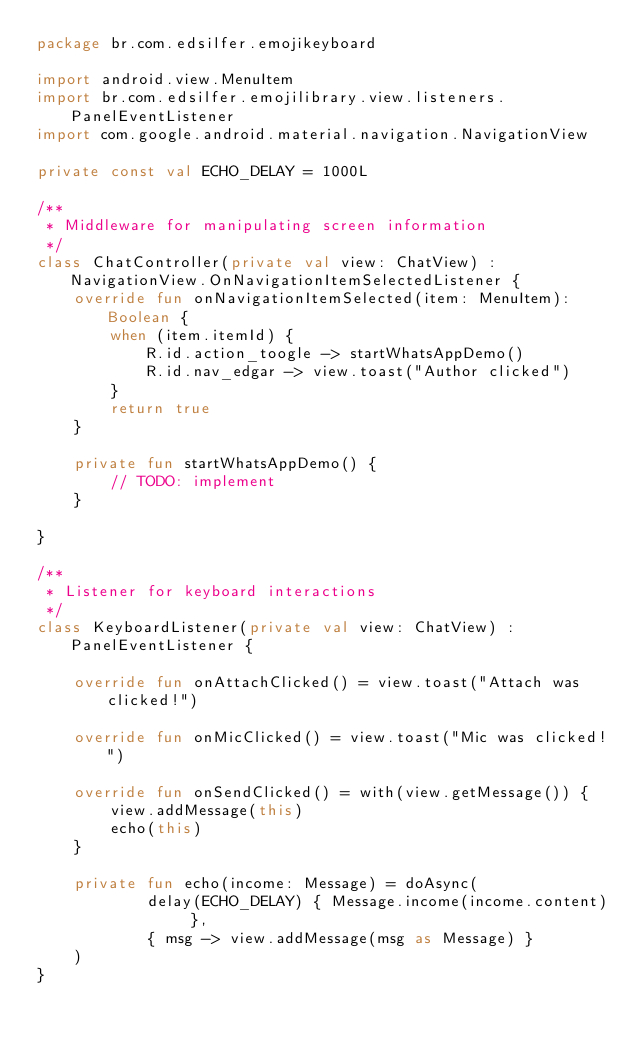Convert code to text. <code><loc_0><loc_0><loc_500><loc_500><_Kotlin_>package br.com.edsilfer.emojikeyboard

import android.view.MenuItem
import br.com.edsilfer.emojilibrary.view.listeners.PanelEventListener
import com.google.android.material.navigation.NavigationView

private const val ECHO_DELAY = 1000L

/**
 * Middleware for manipulating screen information
 */
class ChatController(private val view: ChatView) : NavigationView.OnNavigationItemSelectedListener {
    override fun onNavigationItemSelected(item: MenuItem): Boolean {
        when (item.itemId) {
            R.id.action_toogle -> startWhatsAppDemo()
            R.id.nav_edgar -> view.toast("Author clicked")
        }
        return true
    }

    private fun startWhatsAppDemo() {
        // TODO: implement
    }

}

/**
 * Listener for keyboard interactions
 */
class KeyboardListener(private val view: ChatView) : PanelEventListener {

    override fun onAttachClicked() = view.toast("Attach was clicked!")

    override fun onMicClicked() = view.toast("Mic was clicked!")

    override fun onSendClicked() = with(view.getMessage()) {
        view.addMessage(this)
        echo(this)
    }

    private fun echo(income: Message) = doAsync(
            delay(ECHO_DELAY) { Message.income(income.content) },
            { msg -> view.addMessage(msg as Message) }
    )
}</code> 